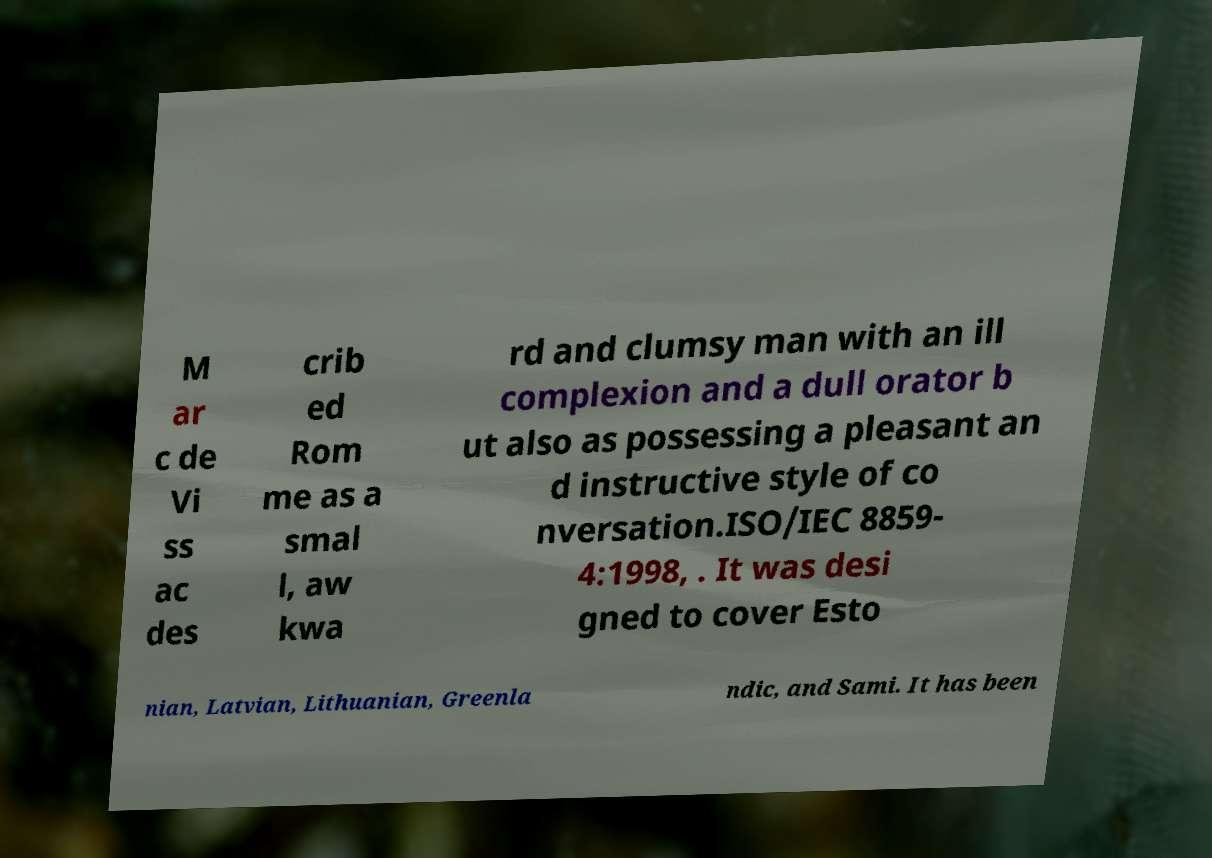Can you accurately transcribe the text from the provided image for me? M ar c de Vi ss ac des crib ed Rom me as a smal l, aw kwa rd and clumsy man with an ill complexion and a dull orator b ut also as possessing a pleasant an d instructive style of co nversation.ISO/IEC 8859- 4:1998, . It was desi gned to cover Esto nian, Latvian, Lithuanian, Greenla ndic, and Sami. It has been 